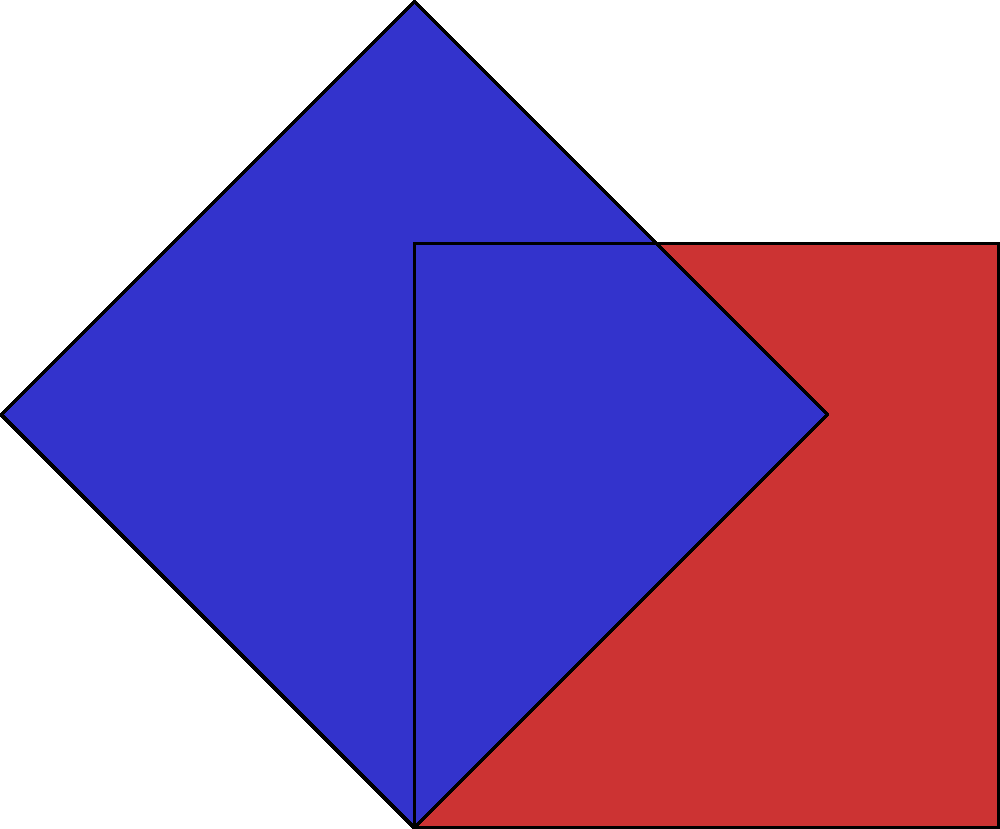In the context of algorithmic art generation, consider a square with side length 1 unit. If we apply a rotation of 45 degrees followed by a scaling factor of $\sqrt{2}$, what will be the area of the resulting shape in relation to the original square? Let's approach this step-by-step:

1. The original square has a side length of 1 unit, so its area is:
   $A_1 = 1^2 = 1$ square unit

2. Rotating the square by 45 degrees doesn't change its area, so after rotation, the area is still 1 square unit.

3. Now, we apply a scaling factor of $\sqrt{2}$. Scaling affects both dimensions of the shape. If we scale a shape by a factor $k$, its area is multiplied by $k^2$.

4. In this case, our scaling factor is $\sqrt{2}$, so the new area will be:
   $A_2 = A_1 \times (\sqrt{2})^2 = 1 \times 2 = 2$ square units

5. To express this in relation to the original square, we can say that the new area is:
   $\frac{A_2}{A_1} = \frac{2}{1} = 2$

Therefore, the area of the resulting shape is 2 times the area of the original square.
Answer: 2 times the original area 